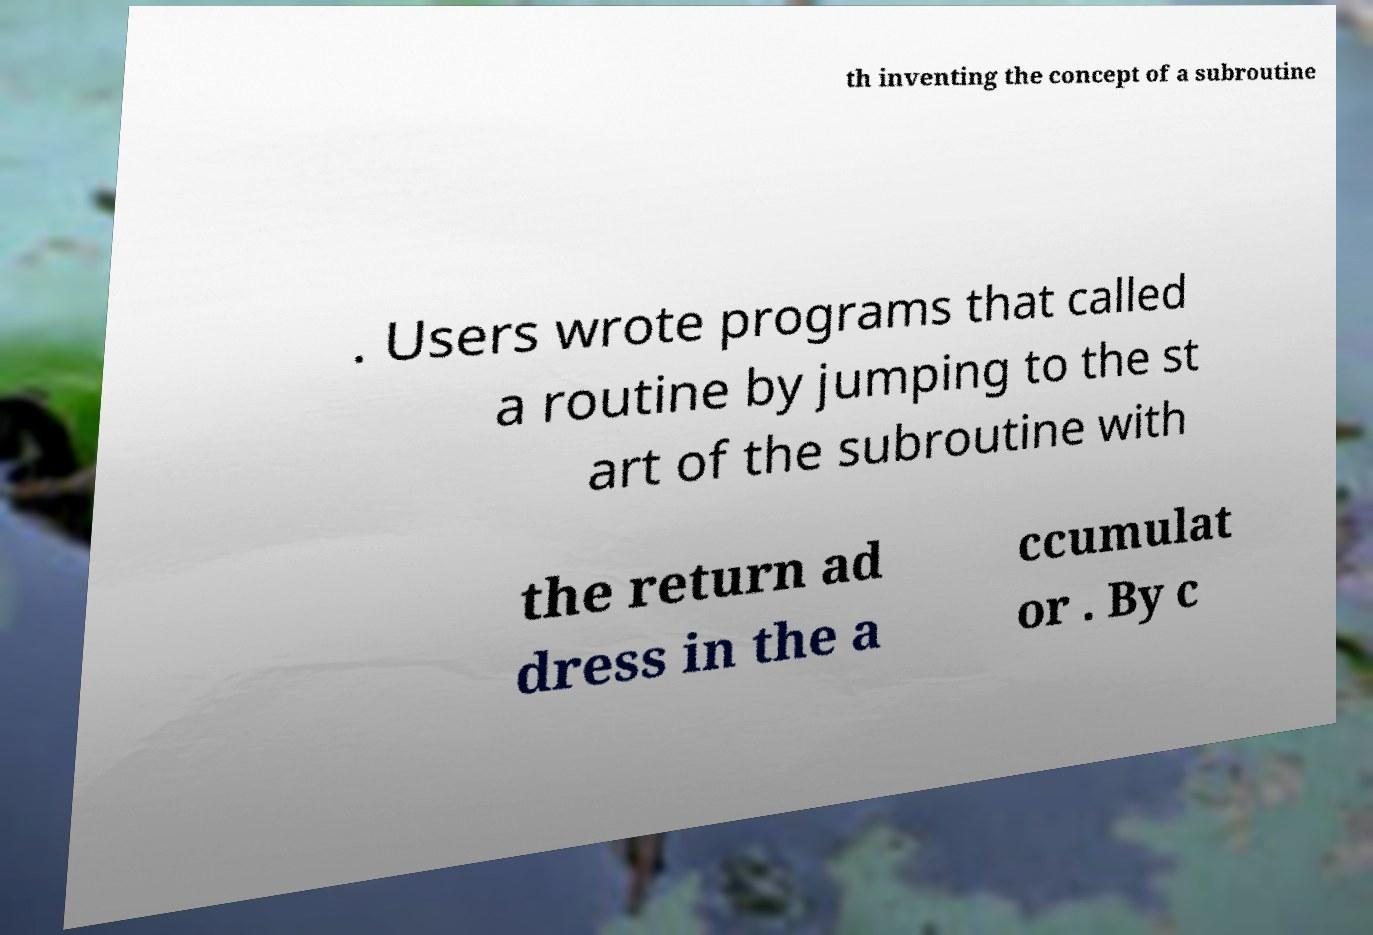Can you read and provide the text displayed in the image?This photo seems to have some interesting text. Can you extract and type it out for me? th inventing the concept of a subroutine . Users wrote programs that called a routine by jumping to the st art of the subroutine with the return ad dress in the a ccumulat or . By c 